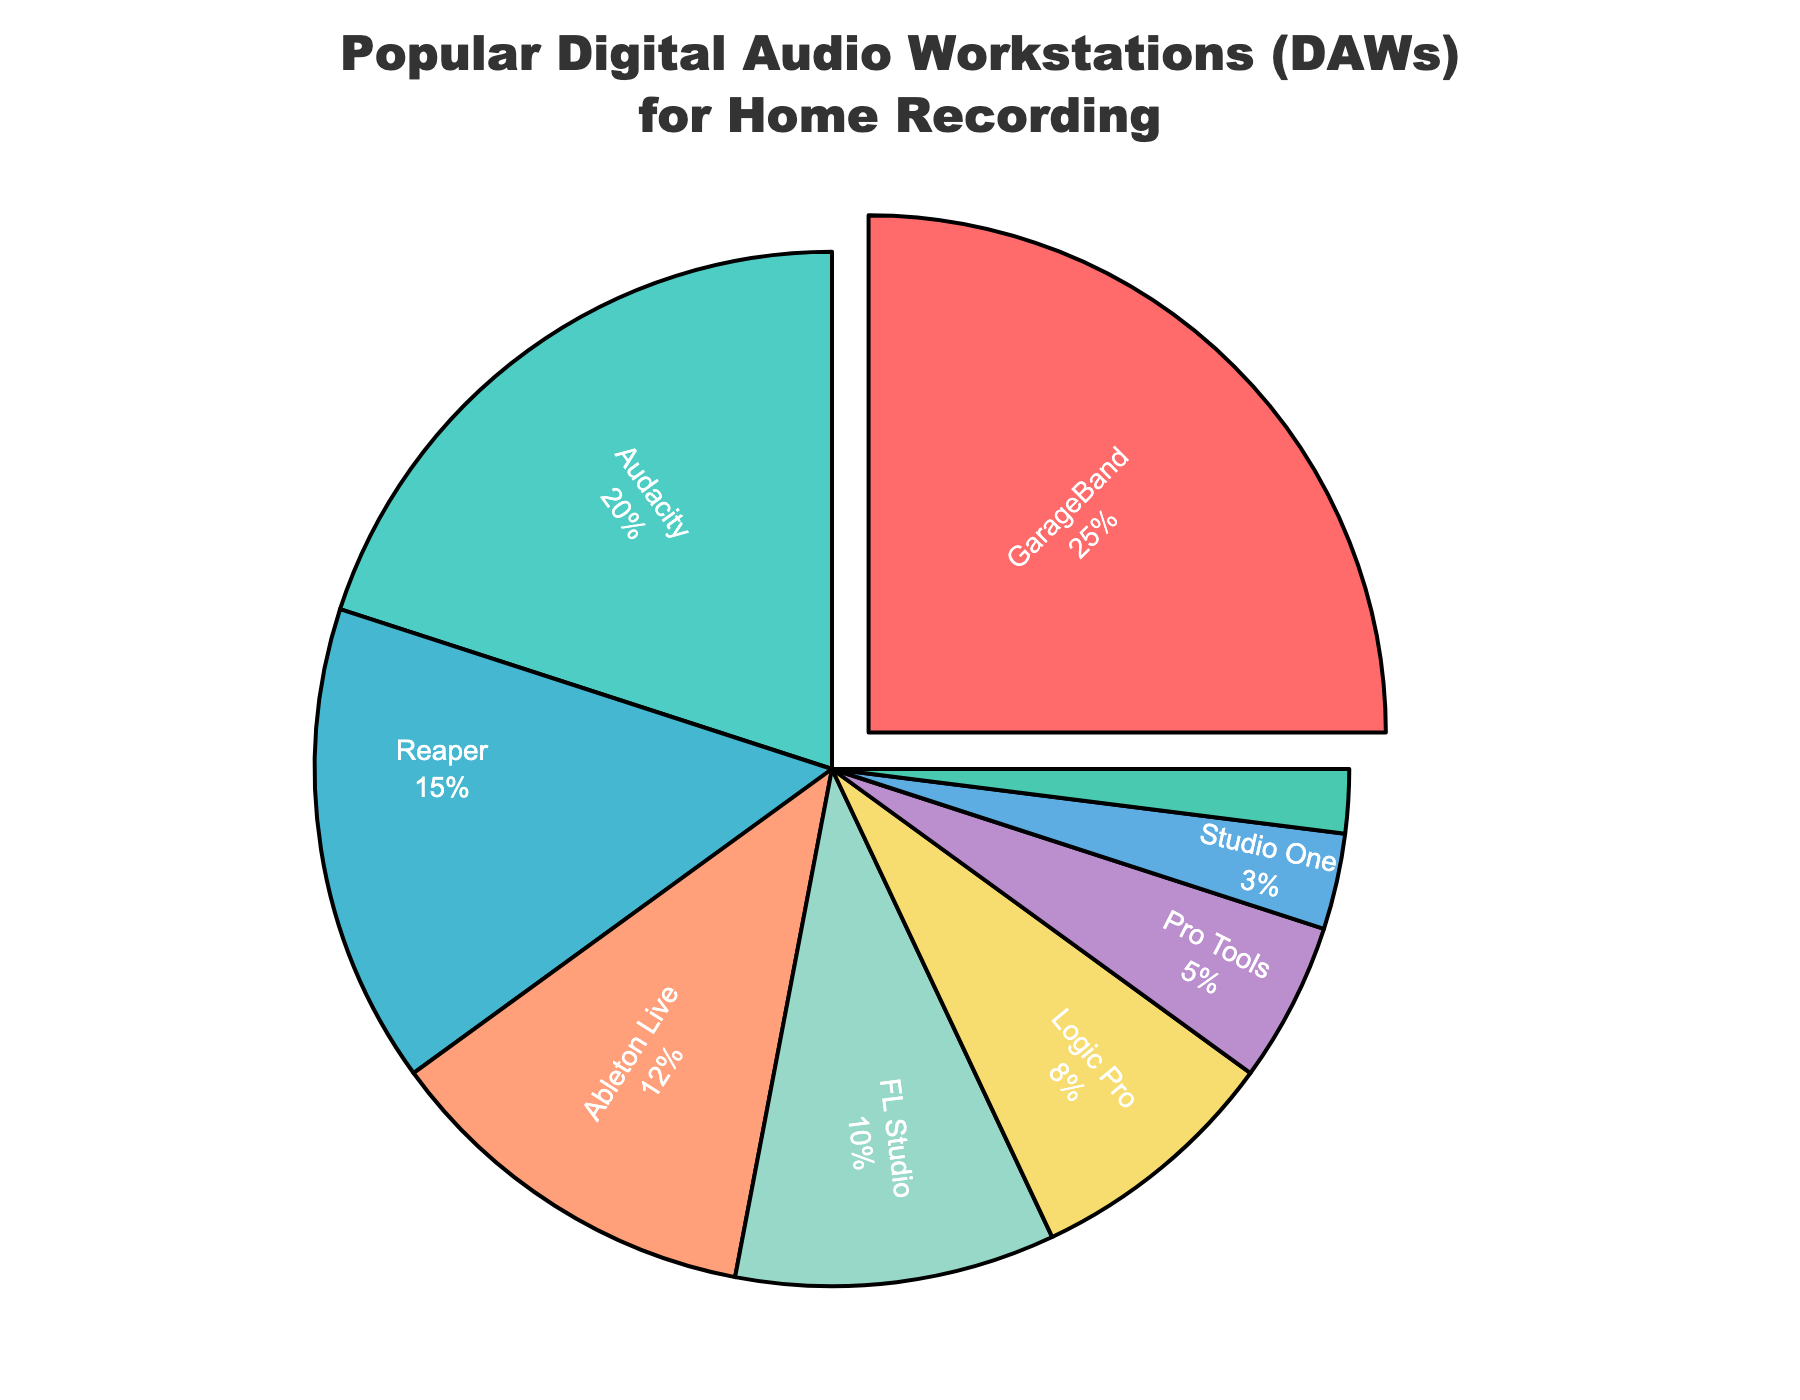Which DAW has the largest market share in home recording? By looking at the pie chart, you can see that GarageBand has the biggest segment pulled out from the pie, indicating it's the largest.
Answer: GarageBand What is the total market share of DAWs with less than 10% usage? Add the percentages of Logic Pro (8%), Pro Tools (5%), Studio One (3%), and Cakewalk (2%). 8 + 5 + 3 + 2 = 18
Answer: 18% Which DAW has a slightly higher market share, Ableton Live or FL Studio? Look at the segments representing Ableton Live and FL Studio; Ableton Live has 12%, which is more than FL Studio's 10%.
Answer: Ableton Live What is the combined market share of Reaper and Audacity? Sum the respective percentages of Reaper (15%) and Audacity (20%). 15 + 20 = 35
Answer: 35% How much larger is the market share of GarageBand compared to Pro Tools? Subtract the percentage of Pro Tools (5%) from that of GarageBand (25%). 25 - 5 = 20
Answer: 20% Which DAWs have market shares between 10% and 20%? By checking the pie chart, you can see that Audacity, Reaper, and Ableton Live fall within this range.
Answer: Audacity, Reaper, Ableton Live Which DAW is represented by the green color in the pie chart? The highlighted color green represents the DAW with 20%, which is Audacity.
Answer: Audacity Is the percentage of users using FL Studio greater than those using Logic Pro? Compare FL Studio's percentage (10%) with Logic Pro's percentage (8%). 10% is greater than 8%.
Answer: Yes What's the average market share of GarageBand, FL Studio, and Studio One? Sum the percentages of GarageBand (25%), FL Studio (10%), and Studio One (3%) and divide by 3. (25 + 10 + 3) / 3 = 38 / 3 ≈ 12.67
Answer: 12.67% Which DAW has the smallest market share? Locate the smallest segment in the pie chart, which corresponds to Cakewalk at 2%.
Answer: Cakewalk 